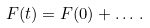Convert formula to latex. <formula><loc_0><loc_0><loc_500><loc_500>F ( t ) = F ( 0 ) + \dots \, .</formula> 